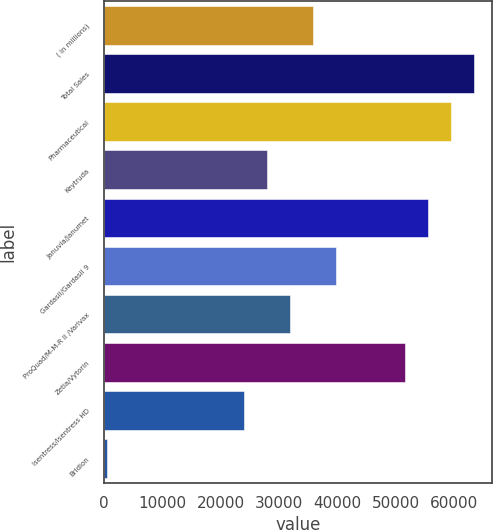Convert chart to OTSL. <chart><loc_0><loc_0><loc_500><loc_500><bar_chart><fcel>( in millions)<fcel>Total Sales<fcel>Pharmaceutical<fcel>Keytruda<fcel>Januvia/Janumet<fcel>Gardasil/Gardasil 9<fcel>ProQuad/M-M-R II /Varivax<fcel>Zetia/Vytorin<fcel>Isentress/Isentress HD<fcel>Bridion<nl><fcel>35874.5<fcel>63402<fcel>59469.5<fcel>28009.5<fcel>55537<fcel>39807<fcel>31942<fcel>51604.5<fcel>24077<fcel>482<nl></chart> 